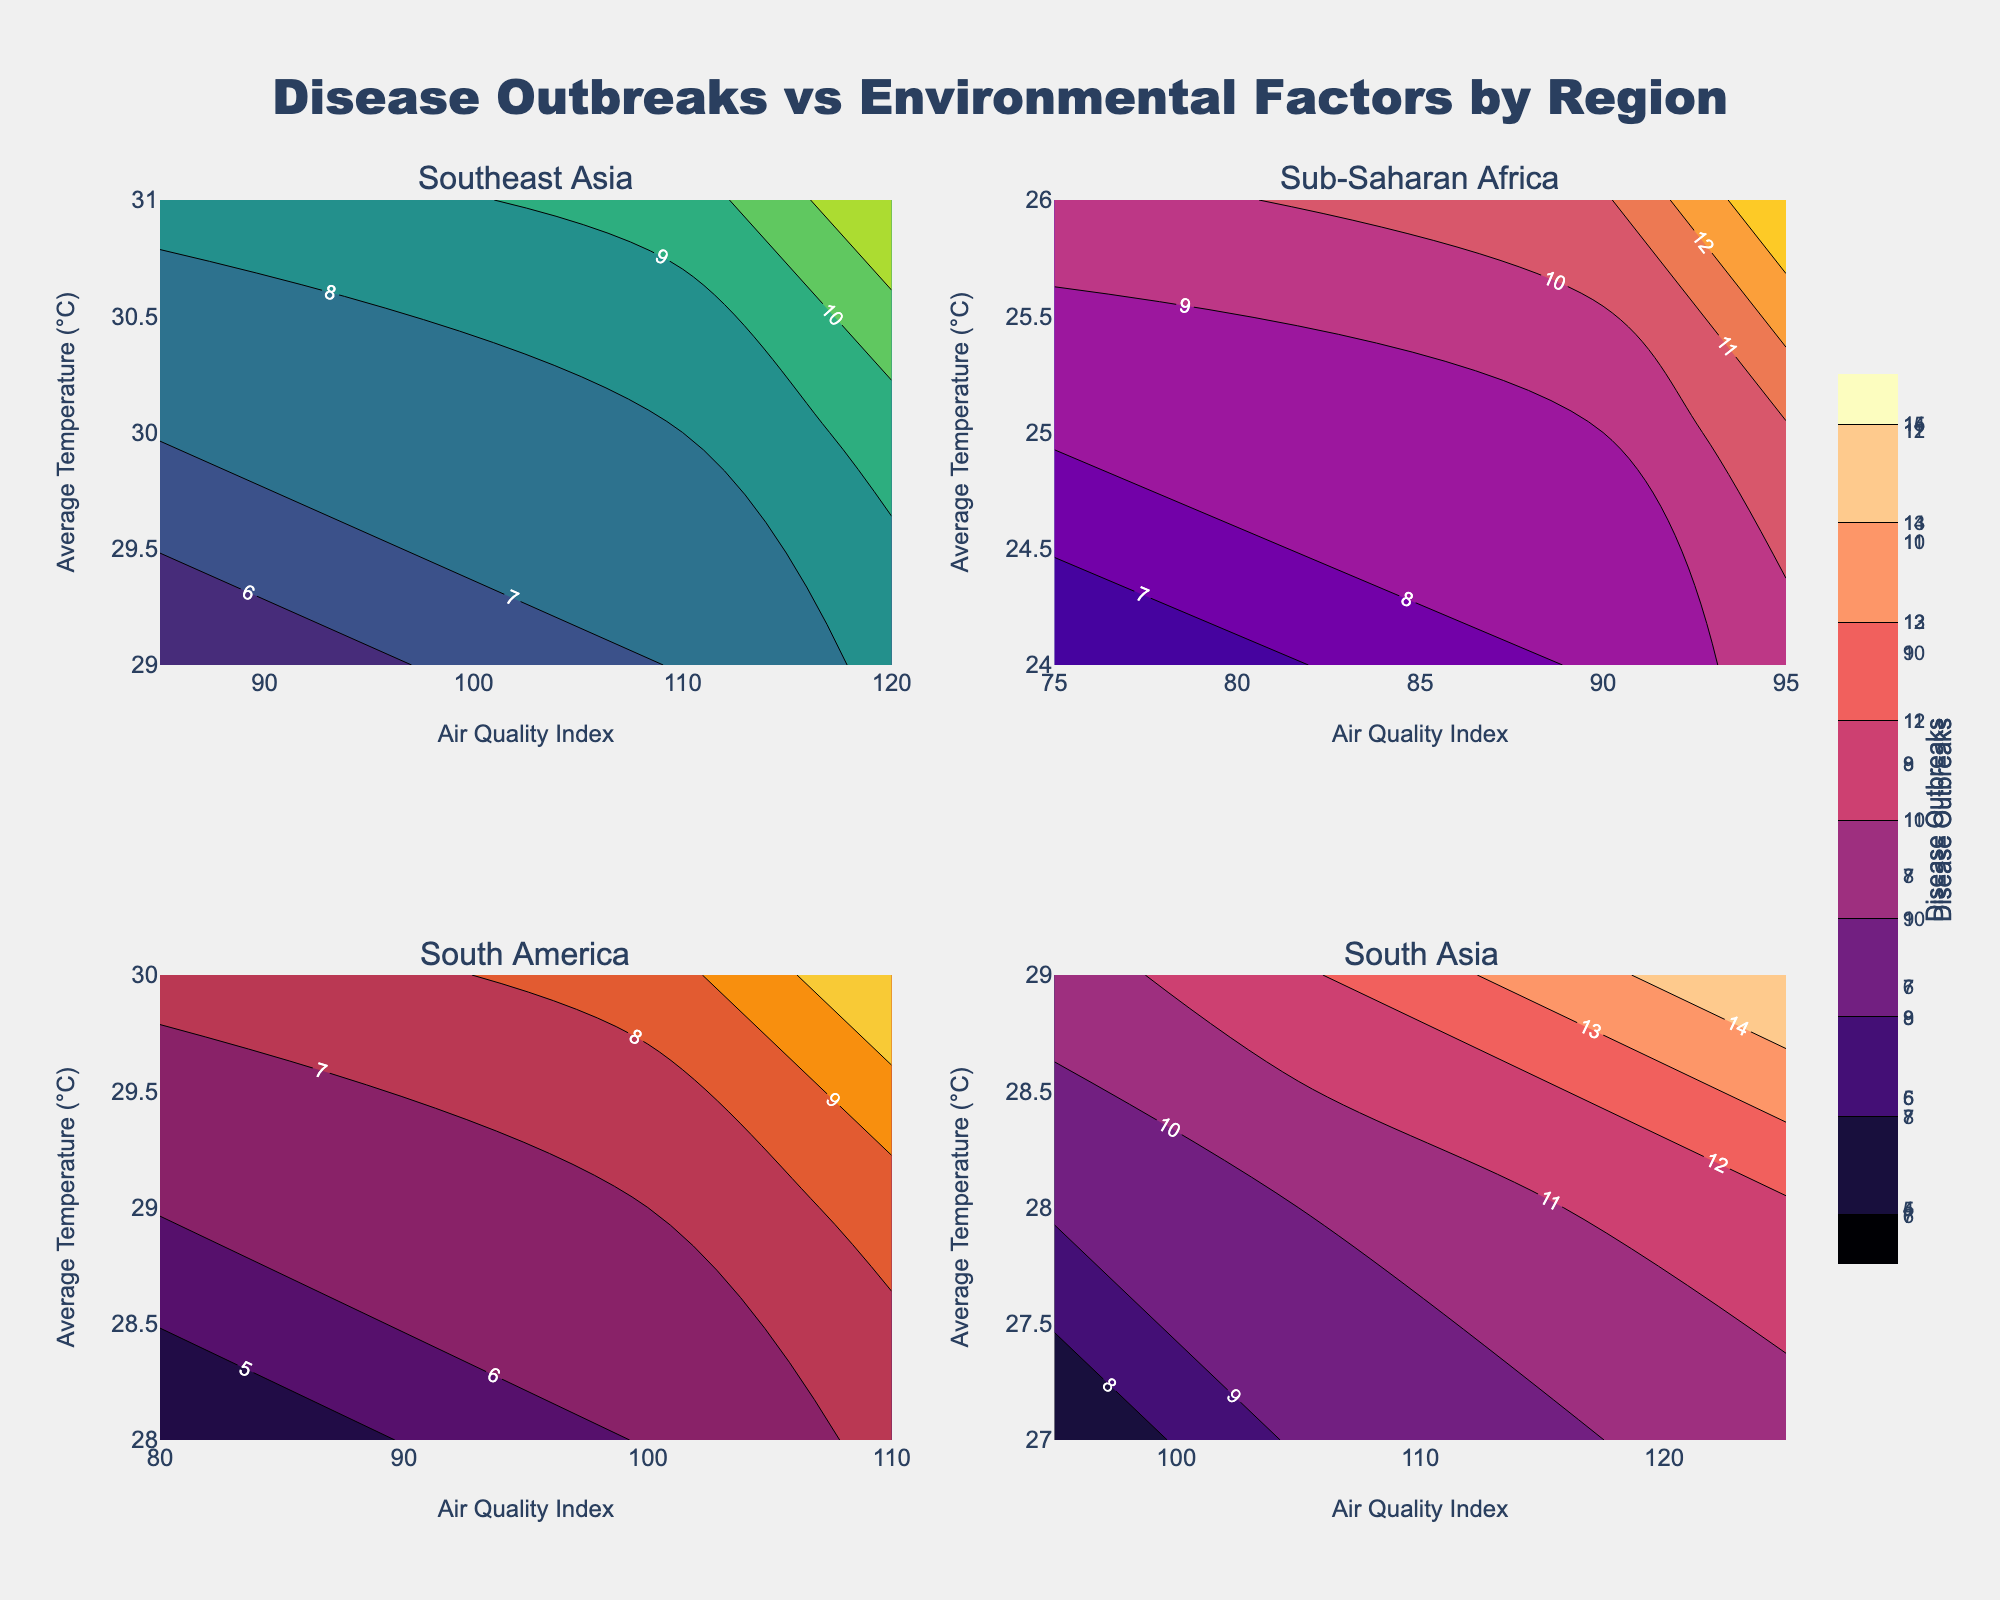What is the title of the figure? The title is usually displayed at the top of the figure, often larger and bolder than other text. Here, it is located at the top center.
Answer: Disease Outbreaks vs Environmental Factors by Region How many sub-plots are in the figure? Examine the structure of the figure; it has four regions, each represented by a subplot. They are arranged in a 2x2 grid layout.
Answer: 4 Which region shows the highest number of disease outbreaks according to the contour plot? By analyzing the contour plots, look for the region with the highest 'Disease Outbreaks' value on the color bar. The presence of the darkest or most intense color indicates a higher value.
Answer: South Asia What is the air quality index range for Southeast Asia in the figure? Check the x-axis for the corresponding subplot of Southeast Asia, which indicates the range of values for the air quality index, typically listed from the minimum to the maximum value covered by the contours.
Answer: 85 to 120 Compare the average temperature ranges between Sub-Saharan Africa and South Asia. Which has the higher average temperature? Look at the y-axes for these regions in their respective subplots and compare the temperature ranges. South Asia has a higher average temperature range.
Answer: South Asia In which region is the relationship between disease outbreaks and the air quality index most apparent? Examine which subplot shows the most significant contour variation along the x-axis (Air Quality Index). South Asia shows strong variation in disease outbreaks corresponding to changes in the air quality index.
Answer: South Asia For South America, what is the general trend between the average temperature and disease outbreaks as visualized in the contour plot? Observe the contour lines in the South America subplot and analyze their direction. If contour lines lean or slope upward or downward, they reflect the trend. As the average temperature increases, the number of disease outbreaks also generally increases.
Answer: Increasing temperature correlates with increasing disease outbreaks Compare the color scales used in the different subplots. Are they the same or different? Note the names or appearances of the color scales in each subplot's legend or visual field. The document indicated different color scales for each subplot, such as 'Viridis' and 'Plasma.'
Answer: Different Between South Asia and Southeast Asia, which has a higher maximum air quality index as shown in their subplots? Refer to the x-axis of each subplot and compare the highest values. South Asia's air quality index reaches up to 125, whereas Southeast Asia reaches 120.
Answer: South Asia 